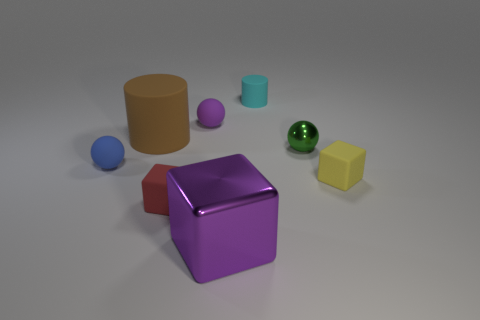What is the color of the tiny shiny sphere?
Make the answer very short. Green. How many tiny balls are the same color as the big shiny cube?
Provide a succinct answer. 1. What number of things are either brown matte cylinders or blocks?
Give a very brief answer. 4. Is the number of yellow matte objects less than the number of shiny objects?
Provide a succinct answer. Yes. There is a brown cylinder that is made of the same material as the purple sphere; what size is it?
Offer a very short reply. Large. The brown cylinder has what size?
Keep it short and to the point. Large. There is a blue rubber thing; what shape is it?
Make the answer very short. Sphere. There is a rubber sphere that is on the right side of the small red rubber block; is its color the same as the metallic block?
Ensure brevity in your answer.  Yes. There is another metallic object that is the same shape as the small yellow thing; what size is it?
Keep it short and to the point. Large. There is a rubber block that is in front of the small cube that is right of the tiny cyan matte cylinder; are there any small things that are to the left of it?
Offer a very short reply. Yes. 